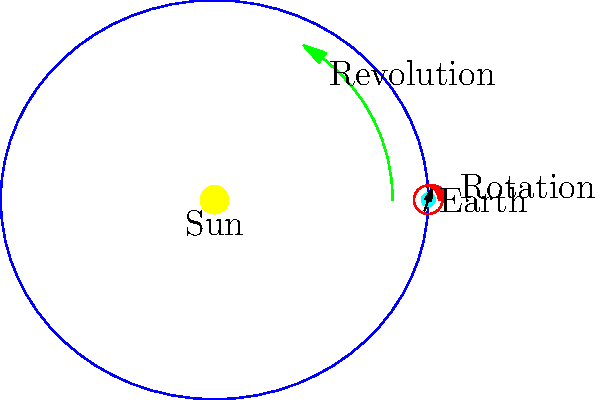As you gear up for the upcoming track and field season, you're explaining to your athletes how Earth's movements relate to their training schedule. In the diagram, which arrow represents the motion responsible for the changing seasons that affect your outdoor practice conditions? Let's break this down step-by-step:

1. The diagram shows two main motions of Earth:
   - A red arrow circling Earth itself
   - A green arrow showing Earth's path around the Sun

2. The red arrow represents Earth's rotation on its axis:
   - This motion is responsible for day and night
   - It occurs approximately every 24 hours
   - This doesn't cause seasonal changes

3. The green arrow represents Earth's revolution around the Sun:
   - This motion is responsible for Earth's yearly orbit
   - It takes approximately 365.25 days to complete

4. Seasons are caused by Earth's axial tilt during its revolution:
   - Earth's axis is tilted at about 23.5 degrees
   - As Earth revolves, different parts receive more direct sunlight
   - This changes the amount of daylight and temperature throughout the year

5. Therefore, the green arrow (revolution) represents the motion responsible for changing seasons:
   - It affects the outdoor practice conditions for your track and field team
   - It determines when you can hold outdoor practices and competitions

The revolution (green arrow) is the key motion that impacts your seasonal training schedule.
Answer: The green arrow (revolution) 